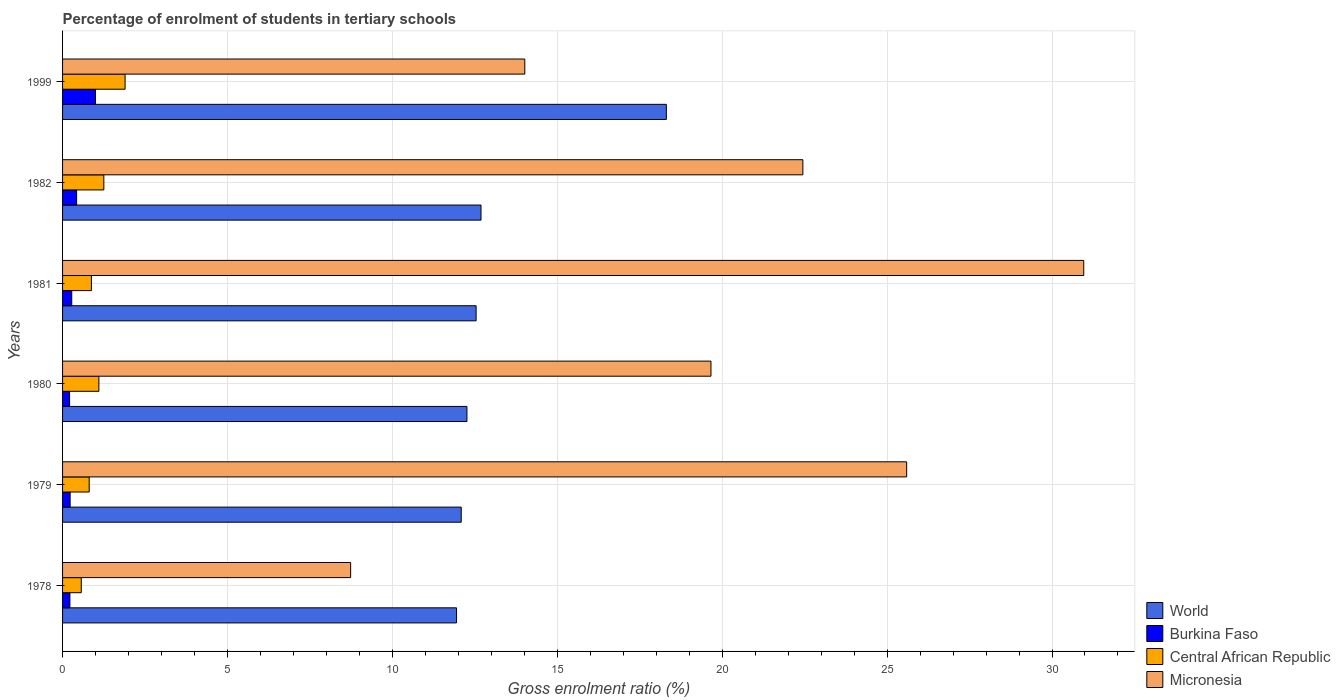How many different coloured bars are there?
Your response must be concise. 4. How many groups of bars are there?
Ensure brevity in your answer.  6. Are the number of bars on each tick of the Y-axis equal?
Provide a succinct answer. Yes. How many bars are there on the 6th tick from the bottom?
Provide a short and direct response. 4. What is the label of the 6th group of bars from the top?
Provide a succinct answer. 1978. What is the percentage of students enrolled in tertiary schools in Central African Republic in 1982?
Ensure brevity in your answer.  1.25. Across all years, what is the maximum percentage of students enrolled in tertiary schools in Burkina Faso?
Give a very brief answer. 1. Across all years, what is the minimum percentage of students enrolled in tertiary schools in Burkina Faso?
Ensure brevity in your answer.  0.21. In which year was the percentage of students enrolled in tertiary schools in Micronesia maximum?
Provide a succinct answer. 1981. In which year was the percentage of students enrolled in tertiary schools in Central African Republic minimum?
Keep it short and to the point. 1978. What is the total percentage of students enrolled in tertiary schools in Central African Republic in the graph?
Your answer should be very brief. 6.5. What is the difference between the percentage of students enrolled in tertiary schools in Micronesia in 1978 and that in 1980?
Give a very brief answer. -10.92. What is the difference between the percentage of students enrolled in tertiary schools in Central African Republic in 1981 and the percentage of students enrolled in tertiary schools in Micronesia in 1978?
Your response must be concise. -7.86. What is the average percentage of students enrolled in tertiary schools in Burkina Faso per year?
Give a very brief answer. 0.39. In the year 1999, what is the difference between the percentage of students enrolled in tertiary schools in Central African Republic and percentage of students enrolled in tertiary schools in Burkina Faso?
Your response must be concise. 0.9. What is the ratio of the percentage of students enrolled in tertiary schools in World in 1978 to that in 1982?
Offer a terse response. 0.94. Is the percentage of students enrolled in tertiary schools in World in 1978 less than that in 1981?
Your answer should be compact. Yes. What is the difference between the highest and the second highest percentage of students enrolled in tertiary schools in Burkina Faso?
Offer a terse response. 0.57. What is the difference between the highest and the lowest percentage of students enrolled in tertiary schools in Central African Republic?
Ensure brevity in your answer.  1.33. In how many years, is the percentage of students enrolled in tertiary schools in Micronesia greater than the average percentage of students enrolled in tertiary schools in Micronesia taken over all years?
Offer a very short reply. 3. Is the sum of the percentage of students enrolled in tertiary schools in Central African Republic in 1978 and 1999 greater than the maximum percentage of students enrolled in tertiary schools in Burkina Faso across all years?
Give a very brief answer. Yes. Is it the case that in every year, the sum of the percentage of students enrolled in tertiary schools in Micronesia and percentage of students enrolled in tertiary schools in Central African Republic is greater than the sum of percentage of students enrolled in tertiary schools in World and percentage of students enrolled in tertiary schools in Burkina Faso?
Make the answer very short. Yes. What does the 2nd bar from the top in 1982 represents?
Your answer should be very brief. Central African Republic. What does the 2nd bar from the bottom in 1980 represents?
Provide a succinct answer. Burkina Faso. Is it the case that in every year, the sum of the percentage of students enrolled in tertiary schools in Central African Republic and percentage of students enrolled in tertiary schools in World is greater than the percentage of students enrolled in tertiary schools in Burkina Faso?
Your response must be concise. Yes. How many bars are there?
Offer a terse response. 24. How many years are there in the graph?
Provide a succinct answer. 6. Are the values on the major ticks of X-axis written in scientific E-notation?
Ensure brevity in your answer.  No. Does the graph contain grids?
Your answer should be compact. Yes. How are the legend labels stacked?
Make the answer very short. Vertical. What is the title of the graph?
Offer a terse response. Percentage of enrolment of students in tertiary schools. Does "American Samoa" appear as one of the legend labels in the graph?
Give a very brief answer. No. What is the Gross enrolment ratio (%) of World in 1978?
Make the answer very short. 11.95. What is the Gross enrolment ratio (%) of Burkina Faso in 1978?
Offer a very short reply. 0.22. What is the Gross enrolment ratio (%) in Central African Republic in 1978?
Offer a very short reply. 0.57. What is the Gross enrolment ratio (%) of Micronesia in 1978?
Keep it short and to the point. 8.73. What is the Gross enrolment ratio (%) of World in 1979?
Offer a very short reply. 12.09. What is the Gross enrolment ratio (%) in Burkina Faso in 1979?
Ensure brevity in your answer.  0.23. What is the Gross enrolment ratio (%) in Central African Republic in 1979?
Provide a short and direct response. 0.81. What is the Gross enrolment ratio (%) in Micronesia in 1979?
Give a very brief answer. 25.59. What is the Gross enrolment ratio (%) in World in 1980?
Your answer should be very brief. 12.26. What is the Gross enrolment ratio (%) in Burkina Faso in 1980?
Your answer should be very brief. 0.21. What is the Gross enrolment ratio (%) in Central African Republic in 1980?
Your answer should be compact. 1.1. What is the Gross enrolment ratio (%) in Micronesia in 1980?
Ensure brevity in your answer.  19.66. What is the Gross enrolment ratio (%) in World in 1981?
Provide a succinct answer. 12.54. What is the Gross enrolment ratio (%) in Burkina Faso in 1981?
Give a very brief answer. 0.28. What is the Gross enrolment ratio (%) of Central African Republic in 1981?
Your answer should be compact. 0.87. What is the Gross enrolment ratio (%) of Micronesia in 1981?
Give a very brief answer. 30.96. What is the Gross enrolment ratio (%) in World in 1982?
Keep it short and to the point. 12.69. What is the Gross enrolment ratio (%) in Burkina Faso in 1982?
Your response must be concise. 0.43. What is the Gross enrolment ratio (%) of Central African Republic in 1982?
Offer a very short reply. 1.25. What is the Gross enrolment ratio (%) of Micronesia in 1982?
Your response must be concise. 22.45. What is the Gross enrolment ratio (%) of World in 1999?
Your answer should be very brief. 18.31. What is the Gross enrolment ratio (%) in Burkina Faso in 1999?
Ensure brevity in your answer.  1. What is the Gross enrolment ratio (%) of Central African Republic in 1999?
Offer a terse response. 1.9. What is the Gross enrolment ratio (%) in Micronesia in 1999?
Make the answer very short. 14.02. Across all years, what is the maximum Gross enrolment ratio (%) of World?
Ensure brevity in your answer.  18.31. Across all years, what is the maximum Gross enrolment ratio (%) in Burkina Faso?
Ensure brevity in your answer.  1. Across all years, what is the maximum Gross enrolment ratio (%) of Central African Republic?
Make the answer very short. 1.9. Across all years, what is the maximum Gross enrolment ratio (%) in Micronesia?
Keep it short and to the point. 30.96. Across all years, what is the minimum Gross enrolment ratio (%) of World?
Provide a short and direct response. 11.95. Across all years, what is the minimum Gross enrolment ratio (%) in Burkina Faso?
Make the answer very short. 0.21. Across all years, what is the minimum Gross enrolment ratio (%) in Central African Republic?
Provide a succinct answer. 0.57. Across all years, what is the minimum Gross enrolment ratio (%) of Micronesia?
Give a very brief answer. 8.73. What is the total Gross enrolment ratio (%) of World in the graph?
Your response must be concise. 79.83. What is the total Gross enrolment ratio (%) in Burkina Faso in the graph?
Give a very brief answer. 2.37. What is the total Gross enrolment ratio (%) of Central African Republic in the graph?
Provide a succinct answer. 6.5. What is the total Gross enrolment ratio (%) in Micronesia in the graph?
Your response must be concise. 121.41. What is the difference between the Gross enrolment ratio (%) in World in 1978 and that in 1979?
Your answer should be very brief. -0.14. What is the difference between the Gross enrolment ratio (%) of Burkina Faso in 1978 and that in 1979?
Offer a terse response. -0.01. What is the difference between the Gross enrolment ratio (%) in Central African Republic in 1978 and that in 1979?
Offer a terse response. -0.24. What is the difference between the Gross enrolment ratio (%) of Micronesia in 1978 and that in 1979?
Provide a short and direct response. -16.86. What is the difference between the Gross enrolment ratio (%) of World in 1978 and that in 1980?
Keep it short and to the point. -0.32. What is the difference between the Gross enrolment ratio (%) in Burkina Faso in 1978 and that in 1980?
Provide a short and direct response. 0.01. What is the difference between the Gross enrolment ratio (%) in Central African Republic in 1978 and that in 1980?
Your answer should be very brief. -0.53. What is the difference between the Gross enrolment ratio (%) of Micronesia in 1978 and that in 1980?
Your answer should be very brief. -10.93. What is the difference between the Gross enrolment ratio (%) in World in 1978 and that in 1981?
Give a very brief answer. -0.59. What is the difference between the Gross enrolment ratio (%) of Burkina Faso in 1978 and that in 1981?
Provide a short and direct response. -0.06. What is the difference between the Gross enrolment ratio (%) in Central African Republic in 1978 and that in 1981?
Make the answer very short. -0.31. What is the difference between the Gross enrolment ratio (%) of Micronesia in 1978 and that in 1981?
Give a very brief answer. -22.23. What is the difference between the Gross enrolment ratio (%) in World in 1978 and that in 1982?
Ensure brevity in your answer.  -0.74. What is the difference between the Gross enrolment ratio (%) of Burkina Faso in 1978 and that in 1982?
Ensure brevity in your answer.  -0.2. What is the difference between the Gross enrolment ratio (%) in Central African Republic in 1978 and that in 1982?
Provide a short and direct response. -0.68. What is the difference between the Gross enrolment ratio (%) of Micronesia in 1978 and that in 1982?
Your response must be concise. -13.71. What is the difference between the Gross enrolment ratio (%) in World in 1978 and that in 1999?
Provide a succinct answer. -6.36. What is the difference between the Gross enrolment ratio (%) of Burkina Faso in 1978 and that in 1999?
Give a very brief answer. -0.78. What is the difference between the Gross enrolment ratio (%) of Central African Republic in 1978 and that in 1999?
Give a very brief answer. -1.33. What is the difference between the Gross enrolment ratio (%) in Micronesia in 1978 and that in 1999?
Make the answer very short. -5.28. What is the difference between the Gross enrolment ratio (%) in World in 1979 and that in 1980?
Give a very brief answer. -0.17. What is the difference between the Gross enrolment ratio (%) of Burkina Faso in 1979 and that in 1980?
Provide a succinct answer. 0.02. What is the difference between the Gross enrolment ratio (%) in Central African Republic in 1979 and that in 1980?
Keep it short and to the point. -0.29. What is the difference between the Gross enrolment ratio (%) of Micronesia in 1979 and that in 1980?
Your response must be concise. 5.93. What is the difference between the Gross enrolment ratio (%) of World in 1979 and that in 1981?
Your response must be concise. -0.45. What is the difference between the Gross enrolment ratio (%) in Burkina Faso in 1979 and that in 1981?
Your answer should be compact. -0.05. What is the difference between the Gross enrolment ratio (%) of Central African Republic in 1979 and that in 1981?
Your response must be concise. -0.07. What is the difference between the Gross enrolment ratio (%) in Micronesia in 1979 and that in 1981?
Give a very brief answer. -5.37. What is the difference between the Gross enrolment ratio (%) of World in 1979 and that in 1982?
Your answer should be compact. -0.6. What is the difference between the Gross enrolment ratio (%) of Burkina Faso in 1979 and that in 1982?
Offer a very short reply. -0.2. What is the difference between the Gross enrolment ratio (%) of Central African Republic in 1979 and that in 1982?
Your response must be concise. -0.44. What is the difference between the Gross enrolment ratio (%) in Micronesia in 1979 and that in 1982?
Ensure brevity in your answer.  3.15. What is the difference between the Gross enrolment ratio (%) in World in 1979 and that in 1999?
Make the answer very short. -6.22. What is the difference between the Gross enrolment ratio (%) of Burkina Faso in 1979 and that in 1999?
Ensure brevity in your answer.  -0.77. What is the difference between the Gross enrolment ratio (%) of Central African Republic in 1979 and that in 1999?
Offer a terse response. -1.09. What is the difference between the Gross enrolment ratio (%) of Micronesia in 1979 and that in 1999?
Your response must be concise. 11.58. What is the difference between the Gross enrolment ratio (%) of World in 1980 and that in 1981?
Your answer should be compact. -0.28. What is the difference between the Gross enrolment ratio (%) in Burkina Faso in 1980 and that in 1981?
Provide a short and direct response. -0.07. What is the difference between the Gross enrolment ratio (%) in Central African Republic in 1980 and that in 1981?
Offer a terse response. 0.23. What is the difference between the Gross enrolment ratio (%) in Micronesia in 1980 and that in 1981?
Your answer should be very brief. -11.3. What is the difference between the Gross enrolment ratio (%) of World in 1980 and that in 1982?
Make the answer very short. -0.43. What is the difference between the Gross enrolment ratio (%) of Burkina Faso in 1980 and that in 1982?
Keep it short and to the point. -0.21. What is the difference between the Gross enrolment ratio (%) in Central African Republic in 1980 and that in 1982?
Provide a short and direct response. -0.15. What is the difference between the Gross enrolment ratio (%) of Micronesia in 1980 and that in 1982?
Give a very brief answer. -2.79. What is the difference between the Gross enrolment ratio (%) of World in 1980 and that in 1999?
Keep it short and to the point. -6.05. What is the difference between the Gross enrolment ratio (%) in Burkina Faso in 1980 and that in 1999?
Give a very brief answer. -0.79. What is the difference between the Gross enrolment ratio (%) in Central African Republic in 1980 and that in 1999?
Provide a short and direct response. -0.79. What is the difference between the Gross enrolment ratio (%) in Micronesia in 1980 and that in 1999?
Provide a succinct answer. 5.64. What is the difference between the Gross enrolment ratio (%) in World in 1981 and that in 1982?
Provide a short and direct response. -0.15. What is the difference between the Gross enrolment ratio (%) in Burkina Faso in 1981 and that in 1982?
Offer a terse response. -0.15. What is the difference between the Gross enrolment ratio (%) in Central African Republic in 1981 and that in 1982?
Make the answer very short. -0.38. What is the difference between the Gross enrolment ratio (%) of Micronesia in 1981 and that in 1982?
Your answer should be compact. 8.52. What is the difference between the Gross enrolment ratio (%) in World in 1981 and that in 1999?
Provide a short and direct response. -5.77. What is the difference between the Gross enrolment ratio (%) in Burkina Faso in 1981 and that in 1999?
Keep it short and to the point. -0.72. What is the difference between the Gross enrolment ratio (%) of Central African Republic in 1981 and that in 1999?
Offer a very short reply. -1.02. What is the difference between the Gross enrolment ratio (%) in Micronesia in 1981 and that in 1999?
Keep it short and to the point. 16.95. What is the difference between the Gross enrolment ratio (%) of World in 1982 and that in 1999?
Provide a short and direct response. -5.62. What is the difference between the Gross enrolment ratio (%) in Burkina Faso in 1982 and that in 1999?
Give a very brief answer. -0.57. What is the difference between the Gross enrolment ratio (%) in Central African Republic in 1982 and that in 1999?
Make the answer very short. -0.64. What is the difference between the Gross enrolment ratio (%) of Micronesia in 1982 and that in 1999?
Make the answer very short. 8.43. What is the difference between the Gross enrolment ratio (%) of World in 1978 and the Gross enrolment ratio (%) of Burkina Faso in 1979?
Make the answer very short. 11.72. What is the difference between the Gross enrolment ratio (%) in World in 1978 and the Gross enrolment ratio (%) in Central African Republic in 1979?
Your answer should be very brief. 11.14. What is the difference between the Gross enrolment ratio (%) in World in 1978 and the Gross enrolment ratio (%) in Micronesia in 1979?
Make the answer very short. -13.65. What is the difference between the Gross enrolment ratio (%) of Burkina Faso in 1978 and the Gross enrolment ratio (%) of Central African Republic in 1979?
Provide a succinct answer. -0.58. What is the difference between the Gross enrolment ratio (%) of Burkina Faso in 1978 and the Gross enrolment ratio (%) of Micronesia in 1979?
Ensure brevity in your answer.  -25.37. What is the difference between the Gross enrolment ratio (%) of Central African Republic in 1978 and the Gross enrolment ratio (%) of Micronesia in 1979?
Keep it short and to the point. -25.03. What is the difference between the Gross enrolment ratio (%) in World in 1978 and the Gross enrolment ratio (%) in Burkina Faso in 1980?
Your answer should be compact. 11.73. What is the difference between the Gross enrolment ratio (%) of World in 1978 and the Gross enrolment ratio (%) of Central African Republic in 1980?
Make the answer very short. 10.84. What is the difference between the Gross enrolment ratio (%) of World in 1978 and the Gross enrolment ratio (%) of Micronesia in 1980?
Give a very brief answer. -7.71. What is the difference between the Gross enrolment ratio (%) in Burkina Faso in 1978 and the Gross enrolment ratio (%) in Central African Republic in 1980?
Make the answer very short. -0.88. What is the difference between the Gross enrolment ratio (%) of Burkina Faso in 1978 and the Gross enrolment ratio (%) of Micronesia in 1980?
Offer a very short reply. -19.44. What is the difference between the Gross enrolment ratio (%) in Central African Republic in 1978 and the Gross enrolment ratio (%) in Micronesia in 1980?
Keep it short and to the point. -19.09. What is the difference between the Gross enrolment ratio (%) of World in 1978 and the Gross enrolment ratio (%) of Burkina Faso in 1981?
Give a very brief answer. 11.67. What is the difference between the Gross enrolment ratio (%) in World in 1978 and the Gross enrolment ratio (%) in Central African Republic in 1981?
Keep it short and to the point. 11.07. What is the difference between the Gross enrolment ratio (%) of World in 1978 and the Gross enrolment ratio (%) of Micronesia in 1981?
Make the answer very short. -19.02. What is the difference between the Gross enrolment ratio (%) of Burkina Faso in 1978 and the Gross enrolment ratio (%) of Central African Republic in 1981?
Your answer should be very brief. -0.65. What is the difference between the Gross enrolment ratio (%) in Burkina Faso in 1978 and the Gross enrolment ratio (%) in Micronesia in 1981?
Offer a terse response. -30.74. What is the difference between the Gross enrolment ratio (%) in Central African Republic in 1978 and the Gross enrolment ratio (%) in Micronesia in 1981?
Give a very brief answer. -30.4. What is the difference between the Gross enrolment ratio (%) in World in 1978 and the Gross enrolment ratio (%) in Burkina Faso in 1982?
Provide a succinct answer. 11.52. What is the difference between the Gross enrolment ratio (%) of World in 1978 and the Gross enrolment ratio (%) of Central African Republic in 1982?
Offer a terse response. 10.69. What is the difference between the Gross enrolment ratio (%) of World in 1978 and the Gross enrolment ratio (%) of Micronesia in 1982?
Your answer should be compact. -10.5. What is the difference between the Gross enrolment ratio (%) of Burkina Faso in 1978 and the Gross enrolment ratio (%) of Central African Republic in 1982?
Provide a succinct answer. -1.03. What is the difference between the Gross enrolment ratio (%) of Burkina Faso in 1978 and the Gross enrolment ratio (%) of Micronesia in 1982?
Your answer should be compact. -22.22. What is the difference between the Gross enrolment ratio (%) in Central African Republic in 1978 and the Gross enrolment ratio (%) in Micronesia in 1982?
Provide a succinct answer. -21.88. What is the difference between the Gross enrolment ratio (%) in World in 1978 and the Gross enrolment ratio (%) in Burkina Faso in 1999?
Your answer should be compact. 10.95. What is the difference between the Gross enrolment ratio (%) of World in 1978 and the Gross enrolment ratio (%) of Central African Republic in 1999?
Ensure brevity in your answer.  10.05. What is the difference between the Gross enrolment ratio (%) of World in 1978 and the Gross enrolment ratio (%) of Micronesia in 1999?
Keep it short and to the point. -2.07. What is the difference between the Gross enrolment ratio (%) in Burkina Faso in 1978 and the Gross enrolment ratio (%) in Central African Republic in 1999?
Your answer should be very brief. -1.67. What is the difference between the Gross enrolment ratio (%) in Burkina Faso in 1978 and the Gross enrolment ratio (%) in Micronesia in 1999?
Your answer should be very brief. -13.79. What is the difference between the Gross enrolment ratio (%) of Central African Republic in 1978 and the Gross enrolment ratio (%) of Micronesia in 1999?
Offer a very short reply. -13.45. What is the difference between the Gross enrolment ratio (%) of World in 1979 and the Gross enrolment ratio (%) of Burkina Faso in 1980?
Keep it short and to the point. 11.87. What is the difference between the Gross enrolment ratio (%) of World in 1979 and the Gross enrolment ratio (%) of Central African Republic in 1980?
Provide a short and direct response. 10.99. What is the difference between the Gross enrolment ratio (%) of World in 1979 and the Gross enrolment ratio (%) of Micronesia in 1980?
Offer a very short reply. -7.57. What is the difference between the Gross enrolment ratio (%) of Burkina Faso in 1979 and the Gross enrolment ratio (%) of Central African Republic in 1980?
Your answer should be very brief. -0.87. What is the difference between the Gross enrolment ratio (%) in Burkina Faso in 1979 and the Gross enrolment ratio (%) in Micronesia in 1980?
Offer a very short reply. -19.43. What is the difference between the Gross enrolment ratio (%) of Central African Republic in 1979 and the Gross enrolment ratio (%) of Micronesia in 1980?
Keep it short and to the point. -18.85. What is the difference between the Gross enrolment ratio (%) in World in 1979 and the Gross enrolment ratio (%) in Burkina Faso in 1981?
Provide a succinct answer. 11.81. What is the difference between the Gross enrolment ratio (%) in World in 1979 and the Gross enrolment ratio (%) in Central African Republic in 1981?
Your answer should be compact. 11.21. What is the difference between the Gross enrolment ratio (%) of World in 1979 and the Gross enrolment ratio (%) of Micronesia in 1981?
Your answer should be compact. -18.87. What is the difference between the Gross enrolment ratio (%) in Burkina Faso in 1979 and the Gross enrolment ratio (%) in Central African Republic in 1981?
Your response must be concise. -0.65. What is the difference between the Gross enrolment ratio (%) of Burkina Faso in 1979 and the Gross enrolment ratio (%) of Micronesia in 1981?
Ensure brevity in your answer.  -30.73. What is the difference between the Gross enrolment ratio (%) in Central African Republic in 1979 and the Gross enrolment ratio (%) in Micronesia in 1981?
Provide a short and direct response. -30.16. What is the difference between the Gross enrolment ratio (%) of World in 1979 and the Gross enrolment ratio (%) of Burkina Faso in 1982?
Offer a terse response. 11.66. What is the difference between the Gross enrolment ratio (%) of World in 1979 and the Gross enrolment ratio (%) of Central African Republic in 1982?
Your response must be concise. 10.84. What is the difference between the Gross enrolment ratio (%) in World in 1979 and the Gross enrolment ratio (%) in Micronesia in 1982?
Provide a short and direct response. -10.36. What is the difference between the Gross enrolment ratio (%) of Burkina Faso in 1979 and the Gross enrolment ratio (%) of Central African Republic in 1982?
Offer a very short reply. -1.02. What is the difference between the Gross enrolment ratio (%) in Burkina Faso in 1979 and the Gross enrolment ratio (%) in Micronesia in 1982?
Give a very brief answer. -22.22. What is the difference between the Gross enrolment ratio (%) of Central African Republic in 1979 and the Gross enrolment ratio (%) of Micronesia in 1982?
Offer a very short reply. -21.64. What is the difference between the Gross enrolment ratio (%) of World in 1979 and the Gross enrolment ratio (%) of Burkina Faso in 1999?
Offer a very short reply. 11.09. What is the difference between the Gross enrolment ratio (%) in World in 1979 and the Gross enrolment ratio (%) in Central African Republic in 1999?
Your answer should be compact. 10.19. What is the difference between the Gross enrolment ratio (%) in World in 1979 and the Gross enrolment ratio (%) in Micronesia in 1999?
Offer a terse response. -1.93. What is the difference between the Gross enrolment ratio (%) in Burkina Faso in 1979 and the Gross enrolment ratio (%) in Central African Republic in 1999?
Offer a terse response. -1.67. What is the difference between the Gross enrolment ratio (%) in Burkina Faso in 1979 and the Gross enrolment ratio (%) in Micronesia in 1999?
Give a very brief answer. -13.79. What is the difference between the Gross enrolment ratio (%) in Central African Republic in 1979 and the Gross enrolment ratio (%) in Micronesia in 1999?
Ensure brevity in your answer.  -13.21. What is the difference between the Gross enrolment ratio (%) of World in 1980 and the Gross enrolment ratio (%) of Burkina Faso in 1981?
Ensure brevity in your answer.  11.98. What is the difference between the Gross enrolment ratio (%) in World in 1980 and the Gross enrolment ratio (%) in Central African Republic in 1981?
Your response must be concise. 11.39. What is the difference between the Gross enrolment ratio (%) of World in 1980 and the Gross enrolment ratio (%) of Micronesia in 1981?
Provide a succinct answer. -18.7. What is the difference between the Gross enrolment ratio (%) of Burkina Faso in 1980 and the Gross enrolment ratio (%) of Central African Republic in 1981?
Give a very brief answer. -0.66. What is the difference between the Gross enrolment ratio (%) in Burkina Faso in 1980 and the Gross enrolment ratio (%) in Micronesia in 1981?
Your response must be concise. -30.75. What is the difference between the Gross enrolment ratio (%) of Central African Republic in 1980 and the Gross enrolment ratio (%) of Micronesia in 1981?
Your response must be concise. -29.86. What is the difference between the Gross enrolment ratio (%) in World in 1980 and the Gross enrolment ratio (%) in Burkina Faso in 1982?
Give a very brief answer. 11.83. What is the difference between the Gross enrolment ratio (%) of World in 1980 and the Gross enrolment ratio (%) of Central African Republic in 1982?
Offer a very short reply. 11.01. What is the difference between the Gross enrolment ratio (%) in World in 1980 and the Gross enrolment ratio (%) in Micronesia in 1982?
Your answer should be compact. -10.19. What is the difference between the Gross enrolment ratio (%) of Burkina Faso in 1980 and the Gross enrolment ratio (%) of Central African Republic in 1982?
Offer a very short reply. -1.04. What is the difference between the Gross enrolment ratio (%) in Burkina Faso in 1980 and the Gross enrolment ratio (%) in Micronesia in 1982?
Offer a terse response. -22.23. What is the difference between the Gross enrolment ratio (%) in Central African Republic in 1980 and the Gross enrolment ratio (%) in Micronesia in 1982?
Keep it short and to the point. -21.34. What is the difference between the Gross enrolment ratio (%) of World in 1980 and the Gross enrolment ratio (%) of Burkina Faso in 1999?
Give a very brief answer. 11.26. What is the difference between the Gross enrolment ratio (%) of World in 1980 and the Gross enrolment ratio (%) of Central African Republic in 1999?
Keep it short and to the point. 10.36. What is the difference between the Gross enrolment ratio (%) in World in 1980 and the Gross enrolment ratio (%) in Micronesia in 1999?
Offer a terse response. -1.75. What is the difference between the Gross enrolment ratio (%) in Burkina Faso in 1980 and the Gross enrolment ratio (%) in Central African Republic in 1999?
Your answer should be very brief. -1.68. What is the difference between the Gross enrolment ratio (%) in Burkina Faso in 1980 and the Gross enrolment ratio (%) in Micronesia in 1999?
Keep it short and to the point. -13.8. What is the difference between the Gross enrolment ratio (%) in Central African Republic in 1980 and the Gross enrolment ratio (%) in Micronesia in 1999?
Offer a terse response. -12.91. What is the difference between the Gross enrolment ratio (%) in World in 1981 and the Gross enrolment ratio (%) in Burkina Faso in 1982?
Keep it short and to the point. 12.11. What is the difference between the Gross enrolment ratio (%) of World in 1981 and the Gross enrolment ratio (%) of Central African Republic in 1982?
Make the answer very short. 11.29. What is the difference between the Gross enrolment ratio (%) in World in 1981 and the Gross enrolment ratio (%) in Micronesia in 1982?
Ensure brevity in your answer.  -9.91. What is the difference between the Gross enrolment ratio (%) of Burkina Faso in 1981 and the Gross enrolment ratio (%) of Central African Republic in 1982?
Keep it short and to the point. -0.97. What is the difference between the Gross enrolment ratio (%) of Burkina Faso in 1981 and the Gross enrolment ratio (%) of Micronesia in 1982?
Keep it short and to the point. -22.17. What is the difference between the Gross enrolment ratio (%) in Central African Republic in 1981 and the Gross enrolment ratio (%) in Micronesia in 1982?
Your answer should be compact. -21.57. What is the difference between the Gross enrolment ratio (%) in World in 1981 and the Gross enrolment ratio (%) in Burkina Faso in 1999?
Make the answer very short. 11.54. What is the difference between the Gross enrolment ratio (%) of World in 1981 and the Gross enrolment ratio (%) of Central African Republic in 1999?
Make the answer very short. 10.64. What is the difference between the Gross enrolment ratio (%) in World in 1981 and the Gross enrolment ratio (%) in Micronesia in 1999?
Make the answer very short. -1.48. What is the difference between the Gross enrolment ratio (%) of Burkina Faso in 1981 and the Gross enrolment ratio (%) of Central African Republic in 1999?
Keep it short and to the point. -1.62. What is the difference between the Gross enrolment ratio (%) in Burkina Faso in 1981 and the Gross enrolment ratio (%) in Micronesia in 1999?
Keep it short and to the point. -13.74. What is the difference between the Gross enrolment ratio (%) in Central African Republic in 1981 and the Gross enrolment ratio (%) in Micronesia in 1999?
Provide a succinct answer. -13.14. What is the difference between the Gross enrolment ratio (%) in World in 1982 and the Gross enrolment ratio (%) in Burkina Faso in 1999?
Provide a succinct answer. 11.69. What is the difference between the Gross enrolment ratio (%) of World in 1982 and the Gross enrolment ratio (%) of Central African Republic in 1999?
Your answer should be very brief. 10.79. What is the difference between the Gross enrolment ratio (%) in World in 1982 and the Gross enrolment ratio (%) in Micronesia in 1999?
Your answer should be compact. -1.33. What is the difference between the Gross enrolment ratio (%) in Burkina Faso in 1982 and the Gross enrolment ratio (%) in Central African Republic in 1999?
Ensure brevity in your answer.  -1.47. What is the difference between the Gross enrolment ratio (%) in Burkina Faso in 1982 and the Gross enrolment ratio (%) in Micronesia in 1999?
Offer a very short reply. -13.59. What is the difference between the Gross enrolment ratio (%) in Central African Republic in 1982 and the Gross enrolment ratio (%) in Micronesia in 1999?
Your response must be concise. -12.76. What is the average Gross enrolment ratio (%) of World per year?
Your answer should be compact. 13.3. What is the average Gross enrolment ratio (%) in Burkina Faso per year?
Offer a terse response. 0.39. What is the average Gross enrolment ratio (%) in Central African Republic per year?
Offer a very short reply. 1.08. What is the average Gross enrolment ratio (%) of Micronesia per year?
Your response must be concise. 20.24. In the year 1978, what is the difference between the Gross enrolment ratio (%) in World and Gross enrolment ratio (%) in Burkina Faso?
Keep it short and to the point. 11.72. In the year 1978, what is the difference between the Gross enrolment ratio (%) in World and Gross enrolment ratio (%) in Central African Republic?
Ensure brevity in your answer.  11.38. In the year 1978, what is the difference between the Gross enrolment ratio (%) of World and Gross enrolment ratio (%) of Micronesia?
Provide a short and direct response. 3.21. In the year 1978, what is the difference between the Gross enrolment ratio (%) in Burkina Faso and Gross enrolment ratio (%) in Central African Republic?
Give a very brief answer. -0.34. In the year 1978, what is the difference between the Gross enrolment ratio (%) of Burkina Faso and Gross enrolment ratio (%) of Micronesia?
Give a very brief answer. -8.51. In the year 1978, what is the difference between the Gross enrolment ratio (%) in Central African Republic and Gross enrolment ratio (%) in Micronesia?
Ensure brevity in your answer.  -8.17. In the year 1979, what is the difference between the Gross enrolment ratio (%) in World and Gross enrolment ratio (%) in Burkina Faso?
Your answer should be compact. 11.86. In the year 1979, what is the difference between the Gross enrolment ratio (%) in World and Gross enrolment ratio (%) in Central African Republic?
Offer a terse response. 11.28. In the year 1979, what is the difference between the Gross enrolment ratio (%) in World and Gross enrolment ratio (%) in Micronesia?
Provide a succinct answer. -13.51. In the year 1979, what is the difference between the Gross enrolment ratio (%) of Burkina Faso and Gross enrolment ratio (%) of Central African Republic?
Your answer should be compact. -0.58. In the year 1979, what is the difference between the Gross enrolment ratio (%) of Burkina Faso and Gross enrolment ratio (%) of Micronesia?
Your response must be concise. -25.36. In the year 1979, what is the difference between the Gross enrolment ratio (%) in Central African Republic and Gross enrolment ratio (%) in Micronesia?
Make the answer very short. -24.79. In the year 1980, what is the difference between the Gross enrolment ratio (%) in World and Gross enrolment ratio (%) in Burkina Faso?
Provide a short and direct response. 12.05. In the year 1980, what is the difference between the Gross enrolment ratio (%) of World and Gross enrolment ratio (%) of Central African Republic?
Your response must be concise. 11.16. In the year 1980, what is the difference between the Gross enrolment ratio (%) of World and Gross enrolment ratio (%) of Micronesia?
Your response must be concise. -7.4. In the year 1980, what is the difference between the Gross enrolment ratio (%) of Burkina Faso and Gross enrolment ratio (%) of Central African Republic?
Your answer should be compact. -0.89. In the year 1980, what is the difference between the Gross enrolment ratio (%) of Burkina Faso and Gross enrolment ratio (%) of Micronesia?
Keep it short and to the point. -19.45. In the year 1980, what is the difference between the Gross enrolment ratio (%) in Central African Republic and Gross enrolment ratio (%) in Micronesia?
Give a very brief answer. -18.56. In the year 1981, what is the difference between the Gross enrolment ratio (%) in World and Gross enrolment ratio (%) in Burkina Faso?
Make the answer very short. 12.26. In the year 1981, what is the difference between the Gross enrolment ratio (%) in World and Gross enrolment ratio (%) in Central African Republic?
Give a very brief answer. 11.66. In the year 1981, what is the difference between the Gross enrolment ratio (%) of World and Gross enrolment ratio (%) of Micronesia?
Provide a succinct answer. -18.42. In the year 1981, what is the difference between the Gross enrolment ratio (%) in Burkina Faso and Gross enrolment ratio (%) in Central African Republic?
Provide a short and direct response. -0.6. In the year 1981, what is the difference between the Gross enrolment ratio (%) of Burkina Faso and Gross enrolment ratio (%) of Micronesia?
Your response must be concise. -30.68. In the year 1981, what is the difference between the Gross enrolment ratio (%) of Central African Republic and Gross enrolment ratio (%) of Micronesia?
Your response must be concise. -30.09. In the year 1982, what is the difference between the Gross enrolment ratio (%) of World and Gross enrolment ratio (%) of Burkina Faso?
Your answer should be very brief. 12.26. In the year 1982, what is the difference between the Gross enrolment ratio (%) of World and Gross enrolment ratio (%) of Central African Republic?
Offer a terse response. 11.44. In the year 1982, what is the difference between the Gross enrolment ratio (%) in World and Gross enrolment ratio (%) in Micronesia?
Your response must be concise. -9.76. In the year 1982, what is the difference between the Gross enrolment ratio (%) in Burkina Faso and Gross enrolment ratio (%) in Central African Republic?
Offer a very short reply. -0.83. In the year 1982, what is the difference between the Gross enrolment ratio (%) in Burkina Faso and Gross enrolment ratio (%) in Micronesia?
Offer a terse response. -22.02. In the year 1982, what is the difference between the Gross enrolment ratio (%) in Central African Republic and Gross enrolment ratio (%) in Micronesia?
Make the answer very short. -21.2. In the year 1999, what is the difference between the Gross enrolment ratio (%) of World and Gross enrolment ratio (%) of Burkina Faso?
Make the answer very short. 17.31. In the year 1999, what is the difference between the Gross enrolment ratio (%) in World and Gross enrolment ratio (%) in Central African Republic?
Offer a terse response. 16.41. In the year 1999, what is the difference between the Gross enrolment ratio (%) in World and Gross enrolment ratio (%) in Micronesia?
Keep it short and to the point. 4.29. In the year 1999, what is the difference between the Gross enrolment ratio (%) of Burkina Faso and Gross enrolment ratio (%) of Central African Republic?
Keep it short and to the point. -0.9. In the year 1999, what is the difference between the Gross enrolment ratio (%) in Burkina Faso and Gross enrolment ratio (%) in Micronesia?
Ensure brevity in your answer.  -13.02. In the year 1999, what is the difference between the Gross enrolment ratio (%) in Central African Republic and Gross enrolment ratio (%) in Micronesia?
Give a very brief answer. -12.12. What is the ratio of the Gross enrolment ratio (%) in Burkina Faso in 1978 to that in 1979?
Your response must be concise. 0.97. What is the ratio of the Gross enrolment ratio (%) in Central African Republic in 1978 to that in 1979?
Offer a very short reply. 0.7. What is the ratio of the Gross enrolment ratio (%) of Micronesia in 1978 to that in 1979?
Make the answer very short. 0.34. What is the ratio of the Gross enrolment ratio (%) in World in 1978 to that in 1980?
Give a very brief answer. 0.97. What is the ratio of the Gross enrolment ratio (%) in Burkina Faso in 1978 to that in 1980?
Offer a very short reply. 1.04. What is the ratio of the Gross enrolment ratio (%) in Central African Republic in 1978 to that in 1980?
Offer a very short reply. 0.51. What is the ratio of the Gross enrolment ratio (%) in Micronesia in 1978 to that in 1980?
Keep it short and to the point. 0.44. What is the ratio of the Gross enrolment ratio (%) of World in 1978 to that in 1981?
Ensure brevity in your answer.  0.95. What is the ratio of the Gross enrolment ratio (%) of Burkina Faso in 1978 to that in 1981?
Provide a short and direct response. 0.8. What is the ratio of the Gross enrolment ratio (%) of Central African Republic in 1978 to that in 1981?
Ensure brevity in your answer.  0.65. What is the ratio of the Gross enrolment ratio (%) in Micronesia in 1978 to that in 1981?
Your response must be concise. 0.28. What is the ratio of the Gross enrolment ratio (%) in World in 1978 to that in 1982?
Provide a succinct answer. 0.94. What is the ratio of the Gross enrolment ratio (%) of Burkina Faso in 1978 to that in 1982?
Keep it short and to the point. 0.52. What is the ratio of the Gross enrolment ratio (%) of Central African Republic in 1978 to that in 1982?
Your answer should be very brief. 0.45. What is the ratio of the Gross enrolment ratio (%) in Micronesia in 1978 to that in 1982?
Your response must be concise. 0.39. What is the ratio of the Gross enrolment ratio (%) of World in 1978 to that in 1999?
Your answer should be compact. 0.65. What is the ratio of the Gross enrolment ratio (%) in Burkina Faso in 1978 to that in 1999?
Offer a terse response. 0.22. What is the ratio of the Gross enrolment ratio (%) in Central African Republic in 1978 to that in 1999?
Provide a short and direct response. 0.3. What is the ratio of the Gross enrolment ratio (%) in Micronesia in 1978 to that in 1999?
Keep it short and to the point. 0.62. What is the ratio of the Gross enrolment ratio (%) in World in 1979 to that in 1980?
Provide a succinct answer. 0.99. What is the ratio of the Gross enrolment ratio (%) of Burkina Faso in 1979 to that in 1980?
Keep it short and to the point. 1.08. What is the ratio of the Gross enrolment ratio (%) of Central African Republic in 1979 to that in 1980?
Your response must be concise. 0.73. What is the ratio of the Gross enrolment ratio (%) of Micronesia in 1979 to that in 1980?
Your answer should be compact. 1.3. What is the ratio of the Gross enrolment ratio (%) in World in 1979 to that in 1981?
Ensure brevity in your answer.  0.96. What is the ratio of the Gross enrolment ratio (%) of Burkina Faso in 1979 to that in 1981?
Your answer should be compact. 0.82. What is the ratio of the Gross enrolment ratio (%) of Central African Republic in 1979 to that in 1981?
Make the answer very short. 0.92. What is the ratio of the Gross enrolment ratio (%) in Micronesia in 1979 to that in 1981?
Keep it short and to the point. 0.83. What is the ratio of the Gross enrolment ratio (%) of World in 1979 to that in 1982?
Keep it short and to the point. 0.95. What is the ratio of the Gross enrolment ratio (%) in Burkina Faso in 1979 to that in 1982?
Make the answer very short. 0.54. What is the ratio of the Gross enrolment ratio (%) of Central African Republic in 1979 to that in 1982?
Keep it short and to the point. 0.65. What is the ratio of the Gross enrolment ratio (%) in Micronesia in 1979 to that in 1982?
Provide a short and direct response. 1.14. What is the ratio of the Gross enrolment ratio (%) in World in 1979 to that in 1999?
Offer a terse response. 0.66. What is the ratio of the Gross enrolment ratio (%) of Burkina Faso in 1979 to that in 1999?
Ensure brevity in your answer.  0.23. What is the ratio of the Gross enrolment ratio (%) in Central African Republic in 1979 to that in 1999?
Offer a very short reply. 0.43. What is the ratio of the Gross enrolment ratio (%) in Micronesia in 1979 to that in 1999?
Give a very brief answer. 1.83. What is the ratio of the Gross enrolment ratio (%) in World in 1980 to that in 1981?
Provide a short and direct response. 0.98. What is the ratio of the Gross enrolment ratio (%) of Burkina Faso in 1980 to that in 1981?
Offer a terse response. 0.77. What is the ratio of the Gross enrolment ratio (%) of Central African Republic in 1980 to that in 1981?
Your answer should be compact. 1.26. What is the ratio of the Gross enrolment ratio (%) in Micronesia in 1980 to that in 1981?
Offer a terse response. 0.63. What is the ratio of the Gross enrolment ratio (%) in World in 1980 to that in 1982?
Offer a terse response. 0.97. What is the ratio of the Gross enrolment ratio (%) of Burkina Faso in 1980 to that in 1982?
Provide a succinct answer. 0.5. What is the ratio of the Gross enrolment ratio (%) of Central African Republic in 1980 to that in 1982?
Offer a very short reply. 0.88. What is the ratio of the Gross enrolment ratio (%) in Micronesia in 1980 to that in 1982?
Offer a very short reply. 0.88. What is the ratio of the Gross enrolment ratio (%) in World in 1980 to that in 1999?
Your response must be concise. 0.67. What is the ratio of the Gross enrolment ratio (%) in Burkina Faso in 1980 to that in 1999?
Provide a short and direct response. 0.21. What is the ratio of the Gross enrolment ratio (%) of Central African Republic in 1980 to that in 1999?
Your response must be concise. 0.58. What is the ratio of the Gross enrolment ratio (%) of Micronesia in 1980 to that in 1999?
Provide a short and direct response. 1.4. What is the ratio of the Gross enrolment ratio (%) of World in 1981 to that in 1982?
Offer a very short reply. 0.99. What is the ratio of the Gross enrolment ratio (%) of Burkina Faso in 1981 to that in 1982?
Your answer should be very brief. 0.65. What is the ratio of the Gross enrolment ratio (%) of Central African Republic in 1981 to that in 1982?
Ensure brevity in your answer.  0.7. What is the ratio of the Gross enrolment ratio (%) in Micronesia in 1981 to that in 1982?
Keep it short and to the point. 1.38. What is the ratio of the Gross enrolment ratio (%) in World in 1981 to that in 1999?
Your answer should be compact. 0.68. What is the ratio of the Gross enrolment ratio (%) of Burkina Faso in 1981 to that in 1999?
Your response must be concise. 0.28. What is the ratio of the Gross enrolment ratio (%) of Central African Republic in 1981 to that in 1999?
Give a very brief answer. 0.46. What is the ratio of the Gross enrolment ratio (%) in Micronesia in 1981 to that in 1999?
Offer a terse response. 2.21. What is the ratio of the Gross enrolment ratio (%) in World in 1982 to that in 1999?
Offer a very short reply. 0.69. What is the ratio of the Gross enrolment ratio (%) of Burkina Faso in 1982 to that in 1999?
Ensure brevity in your answer.  0.43. What is the ratio of the Gross enrolment ratio (%) of Central African Republic in 1982 to that in 1999?
Provide a succinct answer. 0.66. What is the ratio of the Gross enrolment ratio (%) in Micronesia in 1982 to that in 1999?
Your response must be concise. 1.6. What is the difference between the highest and the second highest Gross enrolment ratio (%) of World?
Offer a terse response. 5.62. What is the difference between the highest and the second highest Gross enrolment ratio (%) of Burkina Faso?
Keep it short and to the point. 0.57. What is the difference between the highest and the second highest Gross enrolment ratio (%) of Central African Republic?
Your response must be concise. 0.64. What is the difference between the highest and the second highest Gross enrolment ratio (%) in Micronesia?
Offer a very short reply. 5.37. What is the difference between the highest and the lowest Gross enrolment ratio (%) in World?
Provide a short and direct response. 6.36. What is the difference between the highest and the lowest Gross enrolment ratio (%) in Burkina Faso?
Your answer should be very brief. 0.79. What is the difference between the highest and the lowest Gross enrolment ratio (%) of Central African Republic?
Make the answer very short. 1.33. What is the difference between the highest and the lowest Gross enrolment ratio (%) in Micronesia?
Your answer should be compact. 22.23. 